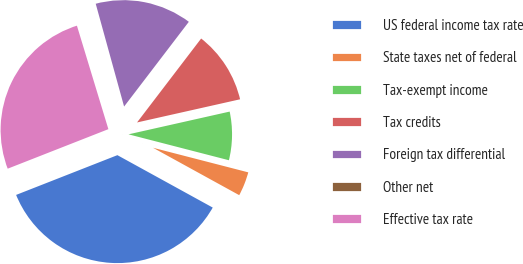Convert chart to OTSL. <chart><loc_0><loc_0><loc_500><loc_500><pie_chart><fcel>US federal income tax rate<fcel>State taxes net of federal<fcel>Tax-exempt income<fcel>Tax credits<fcel>Foreign tax differential<fcel>Other net<fcel>Effective tax rate<nl><fcel>36.05%<fcel>3.98%<fcel>7.54%<fcel>11.1%<fcel>14.67%<fcel>0.41%<fcel>26.26%<nl></chart> 